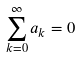Convert formula to latex. <formula><loc_0><loc_0><loc_500><loc_500>\sum _ { k = 0 } ^ { \infty } a _ { k } = 0</formula> 